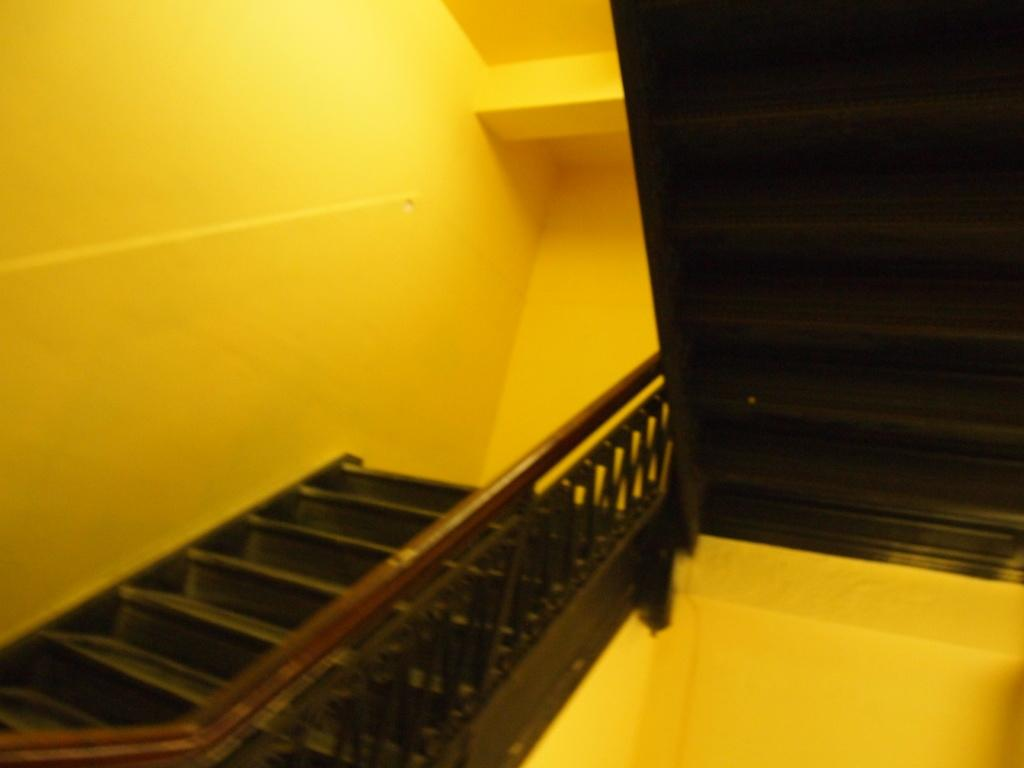What is located in the middle of the image? There are stairs in the middle of the image. What can be seen in the background of the image? There is a wall in the background of the image. What type of store can be seen on the stairs in the image? There is no store present on the stairs in the image; the image only features stairs and a wall in the background. What type of comb is visible in the image? There is no comb present in the image. 